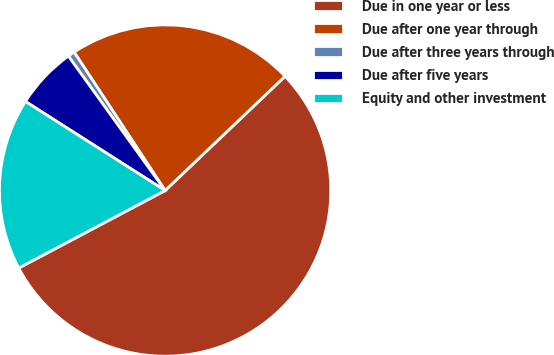Convert chart to OTSL. <chart><loc_0><loc_0><loc_500><loc_500><pie_chart><fcel>Due in one year or less<fcel>Due after one year through<fcel>Due after three years through<fcel>Due after five years<fcel>Equity and other investment<nl><fcel>54.36%<fcel>22.14%<fcel>0.67%<fcel>6.04%<fcel>16.78%<nl></chart> 